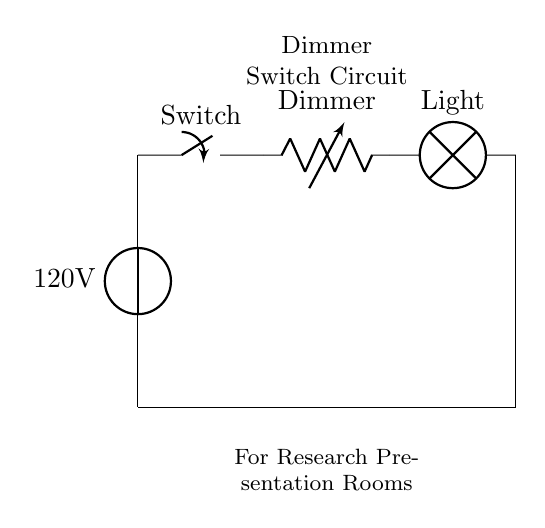What is the voltage of the power source? The circuit shows a voltage of 120 volts at the power source. This is indicated by the label next to the voltage source in the diagram.
Answer: 120 volts What type of component is labeled as "Dimmer"? The "Dimmer" is represented as a variable resistor in the circuit diagram, which allows for the adjustment of resistance to control the brightness of the light.
Answer: Variable resistor How many main components are in the circuit? The circuit consists of four main components: a power source, a switch, a dimmer (variable resistor), and a light bulb. Each component serves a specific function in regulating light.
Answer: Four What happens when the switch is closed? When the switch is closed, it completes the circuit, allowing current to flow from the power source through the dimmer and light bulb, thus illuminating the lamp.
Answer: Current flows What is the purpose of the dimmer in this circuit? The dimmer's purpose is to adjust the brightness of the light by varying the resistance, which changes the current flowing through the light bulb. This enables control over the light level in the room.
Answer: Adjust brightness What type of load is used in this circuit? The load in this circuit is a lamp, which converts electrical energy into light energy. The specific type indicated here is a standard light bulb.
Answer: Lamp 